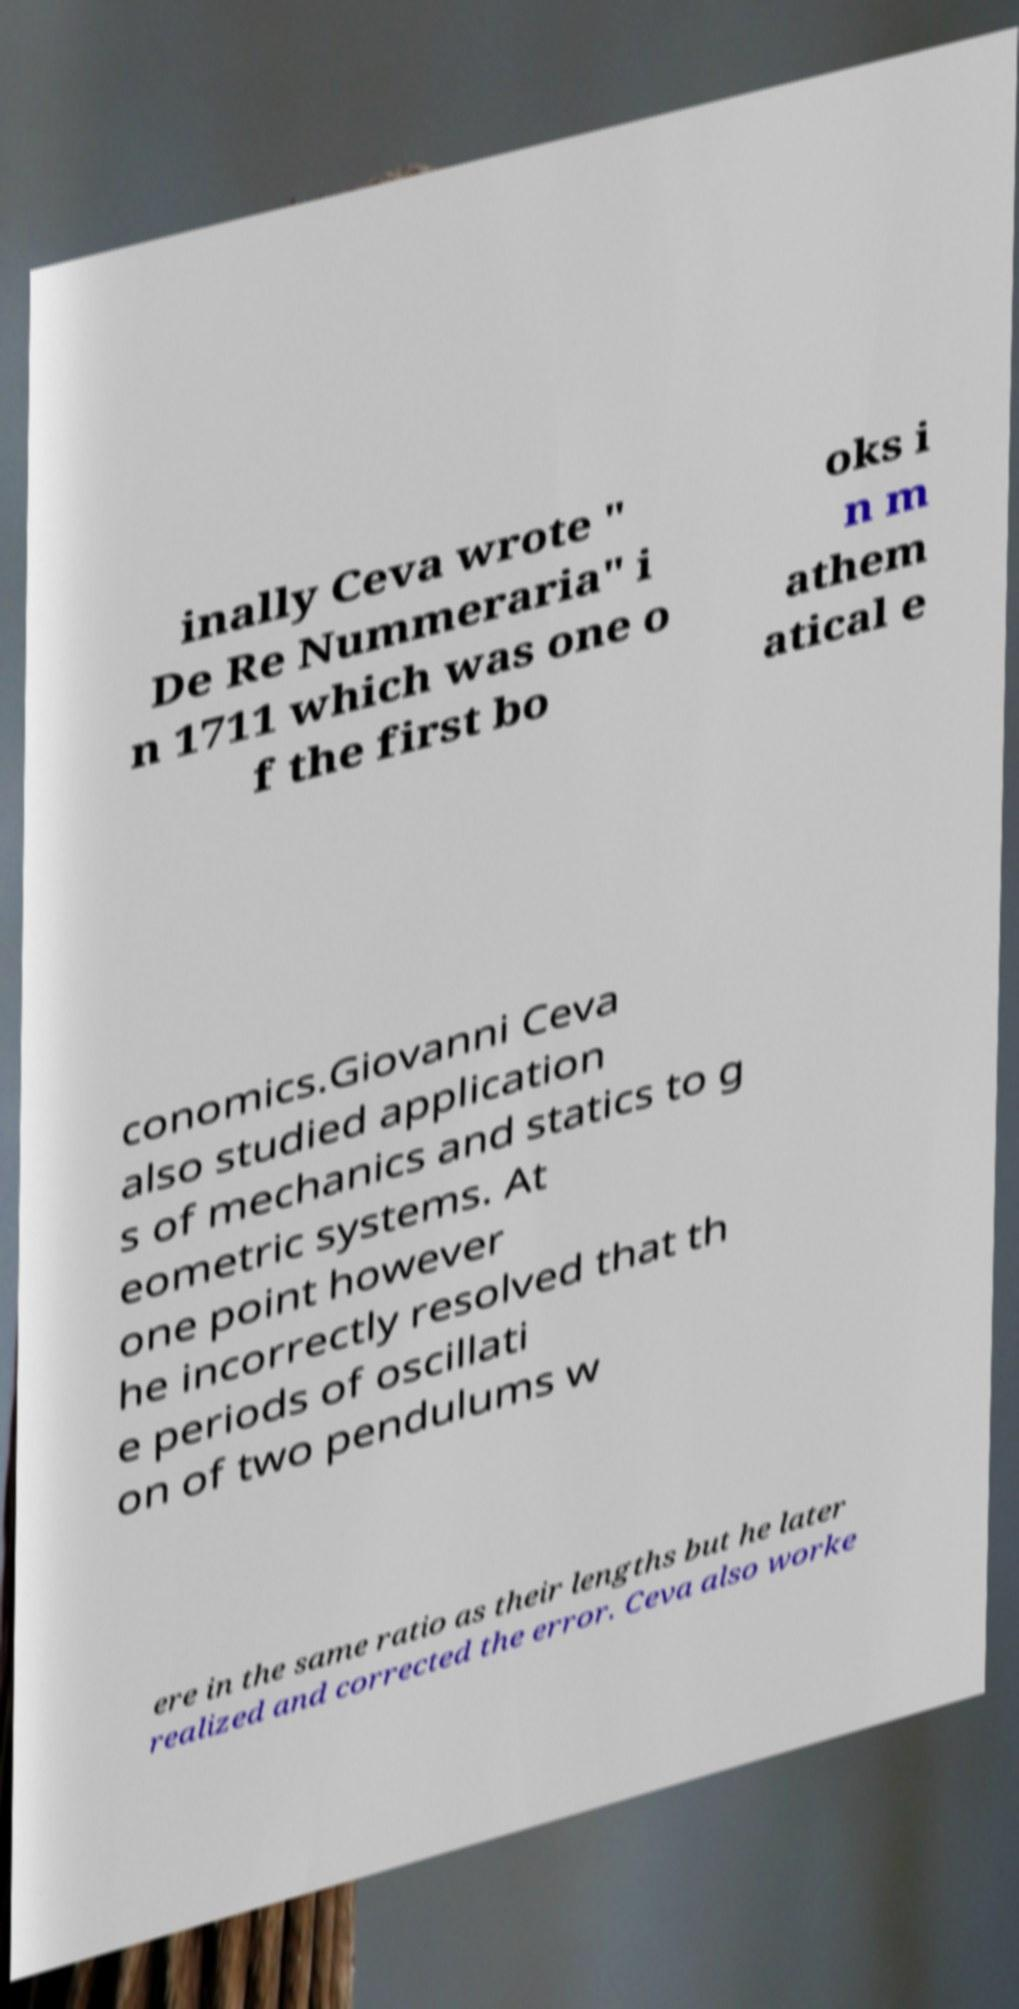Please read and relay the text visible in this image. What does it say? inally Ceva wrote " De Re Nummeraria" i n 1711 which was one o f the first bo oks i n m athem atical e conomics.Giovanni Ceva also studied application s of mechanics and statics to g eometric systems. At one point however he incorrectly resolved that th e periods of oscillati on of two pendulums w ere in the same ratio as their lengths but he later realized and corrected the error. Ceva also worke 